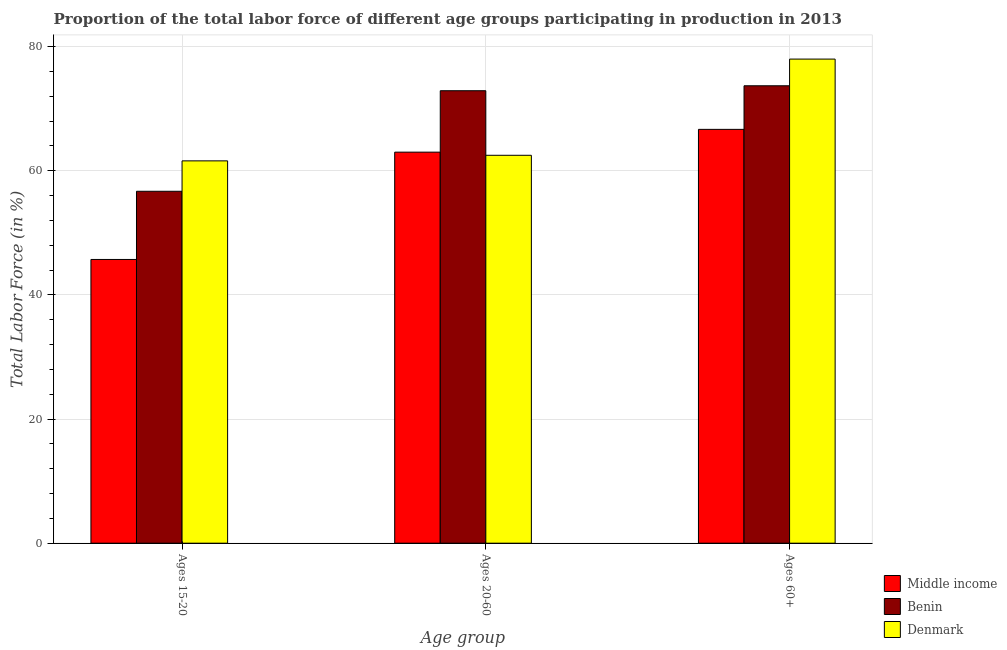Are the number of bars per tick equal to the number of legend labels?
Give a very brief answer. Yes. How many bars are there on the 1st tick from the left?
Keep it short and to the point. 3. What is the label of the 3rd group of bars from the left?
Keep it short and to the point. Ages 60+. What is the percentage of labor force within the age group 15-20 in Middle income?
Your answer should be compact. 45.71. Across all countries, what is the maximum percentage of labor force within the age group 15-20?
Offer a terse response. 61.6. Across all countries, what is the minimum percentage of labor force within the age group 20-60?
Offer a very short reply. 62.5. In which country was the percentage of labor force within the age group 20-60 maximum?
Your answer should be compact. Benin. What is the total percentage of labor force above age 60 in the graph?
Provide a succinct answer. 218.38. What is the difference between the percentage of labor force within the age group 20-60 in Middle income and that in Denmark?
Give a very brief answer. 0.51. What is the difference between the percentage of labor force within the age group 15-20 in Denmark and the percentage of labor force above age 60 in Benin?
Offer a very short reply. -12.1. What is the average percentage of labor force above age 60 per country?
Give a very brief answer. 72.79. What is the difference between the percentage of labor force within the age group 20-60 and percentage of labor force within the age group 15-20 in Middle income?
Offer a very short reply. 17.29. What is the ratio of the percentage of labor force above age 60 in Denmark to that in Benin?
Provide a short and direct response. 1.06. What is the difference between the highest and the second highest percentage of labor force within the age group 20-60?
Your answer should be very brief. 9.89. What is the difference between the highest and the lowest percentage of labor force above age 60?
Make the answer very short. 11.32. In how many countries, is the percentage of labor force within the age group 20-60 greater than the average percentage of labor force within the age group 20-60 taken over all countries?
Keep it short and to the point. 1. Is the sum of the percentage of labor force within the age group 20-60 in Denmark and Middle income greater than the maximum percentage of labor force within the age group 15-20 across all countries?
Make the answer very short. Yes. What does the 3rd bar from the left in Ages 15-20 represents?
Your answer should be very brief. Denmark. What does the 3rd bar from the right in Ages 60+ represents?
Your answer should be very brief. Middle income. Is it the case that in every country, the sum of the percentage of labor force within the age group 15-20 and percentage of labor force within the age group 20-60 is greater than the percentage of labor force above age 60?
Provide a succinct answer. Yes. What is the difference between two consecutive major ticks on the Y-axis?
Offer a very short reply. 20. Does the graph contain any zero values?
Make the answer very short. No. Does the graph contain grids?
Ensure brevity in your answer.  Yes. Where does the legend appear in the graph?
Offer a very short reply. Bottom right. How many legend labels are there?
Your answer should be compact. 3. How are the legend labels stacked?
Give a very brief answer. Vertical. What is the title of the graph?
Your answer should be compact. Proportion of the total labor force of different age groups participating in production in 2013. Does "Sweden" appear as one of the legend labels in the graph?
Provide a short and direct response. No. What is the label or title of the X-axis?
Offer a terse response. Age group. What is the label or title of the Y-axis?
Keep it short and to the point. Total Labor Force (in %). What is the Total Labor Force (in %) in Middle income in Ages 15-20?
Provide a succinct answer. 45.71. What is the Total Labor Force (in %) of Benin in Ages 15-20?
Provide a succinct answer. 56.7. What is the Total Labor Force (in %) in Denmark in Ages 15-20?
Offer a very short reply. 61.6. What is the Total Labor Force (in %) in Middle income in Ages 20-60?
Offer a terse response. 63.01. What is the Total Labor Force (in %) in Benin in Ages 20-60?
Your response must be concise. 72.9. What is the Total Labor Force (in %) in Denmark in Ages 20-60?
Make the answer very short. 62.5. What is the Total Labor Force (in %) of Middle income in Ages 60+?
Your answer should be very brief. 66.68. What is the Total Labor Force (in %) in Benin in Ages 60+?
Give a very brief answer. 73.7. Across all Age group, what is the maximum Total Labor Force (in %) of Middle income?
Offer a very short reply. 66.68. Across all Age group, what is the maximum Total Labor Force (in %) in Benin?
Your answer should be very brief. 73.7. Across all Age group, what is the minimum Total Labor Force (in %) of Middle income?
Offer a terse response. 45.71. Across all Age group, what is the minimum Total Labor Force (in %) of Benin?
Your answer should be compact. 56.7. Across all Age group, what is the minimum Total Labor Force (in %) in Denmark?
Provide a short and direct response. 61.6. What is the total Total Labor Force (in %) of Middle income in the graph?
Your response must be concise. 175.4. What is the total Total Labor Force (in %) in Benin in the graph?
Offer a terse response. 203.3. What is the total Total Labor Force (in %) in Denmark in the graph?
Give a very brief answer. 202.1. What is the difference between the Total Labor Force (in %) in Middle income in Ages 15-20 and that in Ages 20-60?
Keep it short and to the point. -17.29. What is the difference between the Total Labor Force (in %) in Benin in Ages 15-20 and that in Ages 20-60?
Provide a short and direct response. -16.2. What is the difference between the Total Labor Force (in %) in Middle income in Ages 15-20 and that in Ages 60+?
Your answer should be compact. -20.96. What is the difference between the Total Labor Force (in %) in Benin in Ages 15-20 and that in Ages 60+?
Make the answer very short. -17. What is the difference between the Total Labor Force (in %) of Denmark in Ages 15-20 and that in Ages 60+?
Make the answer very short. -16.4. What is the difference between the Total Labor Force (in %) of Middle income in Ages 20-60 and that in Ages 60+?
Make the answer very short. -3.67. What is the difference between the Total Labor Force (in %) in Denmark in Ages 20-60 and that in Ages 60+?
Keep it short and to the point. -15.5. What is the difference between the Total Labor Force (in %) in Middle income in Ages 15-20 and the Total Labor Force (in %) in Benin in Ages 20-60?
Your answer should be very brief. -27.19. What is the difference between the Total Labor Force (in %) in Middle income in Ages 15-20 and the Total Labor Force (in %) in Denmark in Ages 20-60?
Provide a succinct answer. -16.79. What is the difference between the Total Labor Force (in %) in Benin in Ages 15-20 and the Total Labor Force (in %) in Denmark in Ages 20-60?
Offer a terse response. -5.8. What is the difference between the Total Labor Force (in %) in Middle income in Ages 15-20 and the Total Labor Force (in %) in Benin in Ages 60+?
Keep it short and to the point. -27.99. What is the difference between the Total Labor Force (in %) in Middle income in Ages 15-20 and the Total Labor Force (in %) in Denmark in Ages 60+?
Provide a short and direct response. -32.29. What is the difference between the Total Labor Force (in %) in Benin in Ages 15-20 and the Total Labor Force (in %) in Denmark in Ages 60+?
Ensure brevity in your answer.  -21.3. What is the difference between the Total Labor Force (in %) in Middle income in Ages 20-60 and the Total Labor Force (in %) in Benin in Ages 60+?
Your response must be concise. -10.69. What is the difference between the Total Labor Force (in %) in Middle income in Ages 20-60 and the Total Labor Force (in %) in Denmark in Ages 60+?
Provide a short and direct response. -14.99. What is the average Total Labor Force (in %) of Middle income per Age group?
Your answer should be compact. 58.47. What is the average Total Labor Force (in %) of Benin per Age group?
Make the answer very short. 67.77. What is the average Total Labor Force (in %) in Denmark per Age group?
Make the answer very short. 67.37. What is the difference between the Total Labor Force (in %) of Middle income and Total Labor Force (in %) of Benin in Ages 15-20?
Provide a succinct answer. -10.99. What is the difference between the Total Labor Force (in %) of Middle income and Total Labor Force (in %) of Denmark in Ages 15-20?
Your response must be concise. -15.89. What is the difference between the Total Labor Force (in %) in Benin and Total Labor Force (in %) in Denmark in Ages 15-20?
Your answer should be compact. -4.9. What is the difference between the Total Labor Force (in %) of Middle income and Total Labor Force (in %) of Benin in Ages 20-60?
Offer a very short reply. -9.89. What is the difference between the Total Labor Force (in %) of Middle income and Total Labor Force (in %) of Denmark in Ages 20-60?
Keep it short and to the point. 0.51. What is the difference between the Total Labor Force (in %) in Benin and Total Labor Force (in %) in Denmark in Ages 20-60?
Your response must be concise. 10.4. What is the difference between the Total Labor Force (in %) of Middle income and Total Labor Force (in %) of Benin in Ages 60+?
Your answer should be very brief. -7.02. What is the difference between the Total Labor Force (in %) in Middle income and Total Labor Force (in %) in Denmark in Ages 60+?
Give a very brief answer. -11.32. What is the ratio of the Total Labor Force (in %) of Middle income in Ages 15-20 to that in Ages 20-60?
Offer a terse response. 0.73. What is the ratio of the Total Labor Force (in %) in Denmark in Ages 15-20 to that in Ages 20-60?
Offer a very short reply. 0.99. What is the ratio of the Total Labor Force (in %) in Middle income in Ages 15-20 to that in Ages 60+?
Your response must be concise. 0.69. What is the ratio of the Total Labor Force (in %) of Benin in Ages 15-20 to that in Ages 60+?
Make the answer very short. 0.77. What is the ratio of the Total Labor Force (in %) in Denmark in Ages 15-20 to that in Ages 60+?
Provide a short and direct response. 0.79. What is the ratio of the Total Labor Force (in %) in Middle income in Ages 20-60 to that in Ages 60+?
Offer a terse response. 0.94. What is the ratio of the Total Labor Force (in %) of Denmark in Ages 20-60 to that in Ages 60+?
Ensure brevity in your answer.  0.8. What is the difference between the highest and the second highest Total Labor Force (in %) in Middle income?
Offer a terse response. 3.67. What is the difference between the highest and the second highest Total Labor Force (in %) of Benin?
Provide a short and direct response. 0.8. What is the difference between the highest and the lowest Total Labor Force (in %) in Middle income?
Your answer should be very brief. 20.96. What is the difference between the highest and the lowest Total Labor Force (in %) in Benin?
Your answer should be very brief. 17. What is the difference between the highest and the lowest Total Labor Force (in %) of Denmark?
Offer a very short reply. 16.4. 